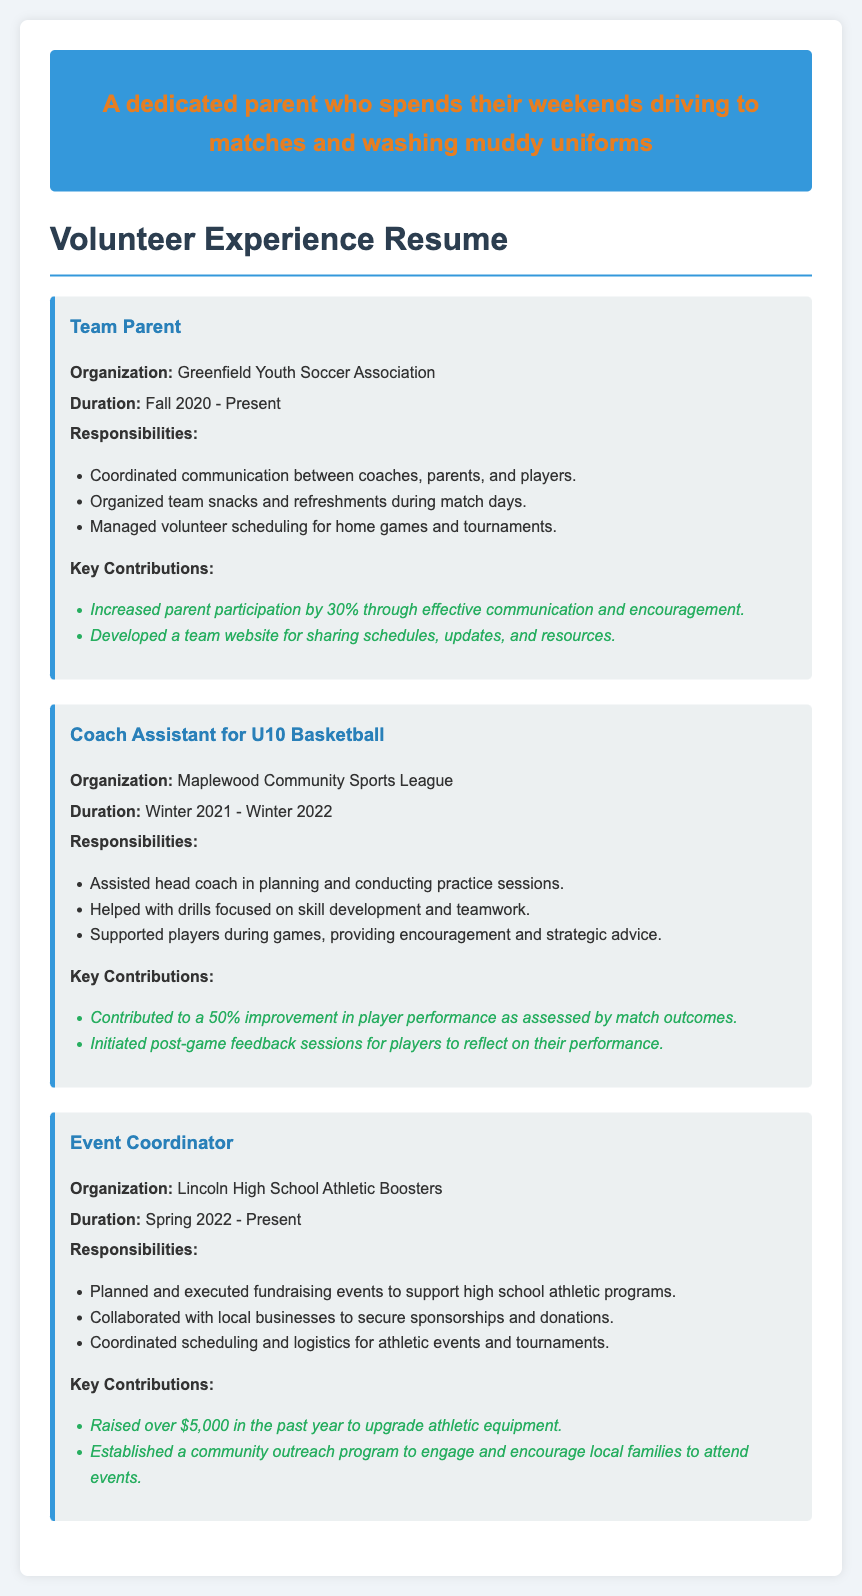What is the name of the organization where the individual served as Team Parent? The individual's role as Team Parent is associated with the Greenfield Youth Soccer Association.
Answer: Greenfield Youth Soccer Association What was the duration of service as Coach Assistant for U10 Basketball? The document states that the individual served from Winter 2021 to Winter 2022.
Answer: Winter 2021 - Winter 2022 How much money was raised by the Event Coordinator in the past year? The document specifies that over $5,000 was raised to upgrade athletic equipment.
Answer: Over $5,000 What percentage increase in parent participation was achieved as Team Parent? The document notes an increase of 30% in parent participation due to effective communication and encouragement.
Answer: 30% What major initiative did the Event Coordinator establish for community engagement? A community outreach program was established to encourage local families to attend events.
Answer: Community outreach program What was the impact of the Coach Assistant's contributions on player performance? The document mentions a contribution leading to a 50% improvement in player performance as assessed by match outcomes.
Answer: 50% improvement 